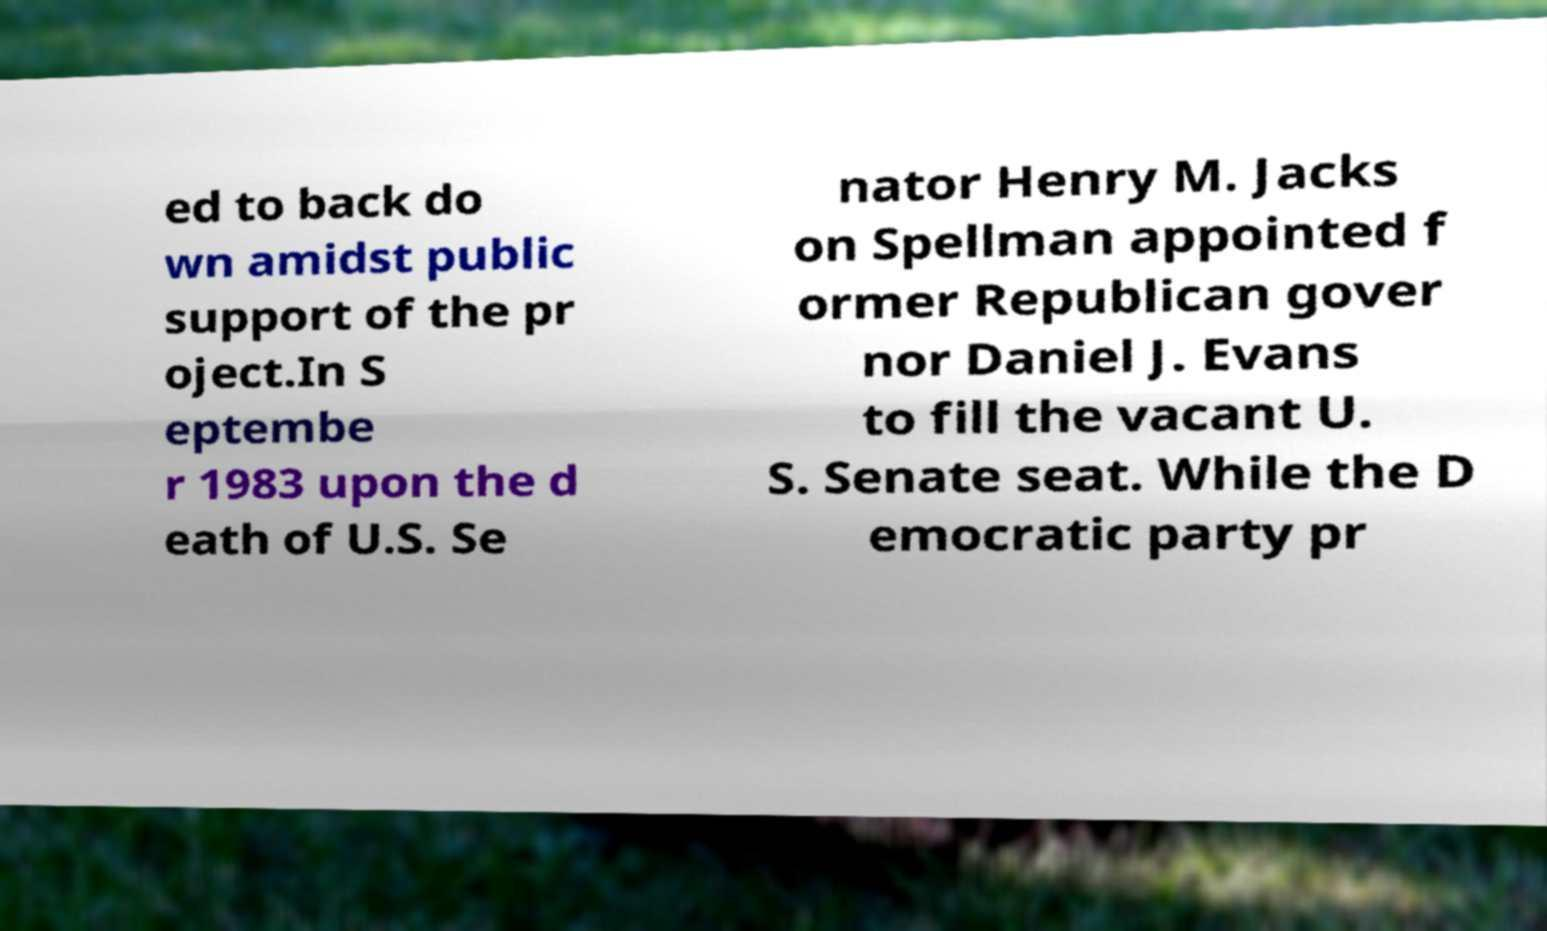Could you assist in decoding the text presented in this image and type it out clearly? ed to back do wn amidst public support of the pr oject.In S eptembe r 1983 upon the d eath of U.S. Se nator Henry M. Jacks on Spellman appointed f ormer Republican gover nor Daniel J. Evans to fill the vacant U. S. Senate seat. While the D emocratic party pr 